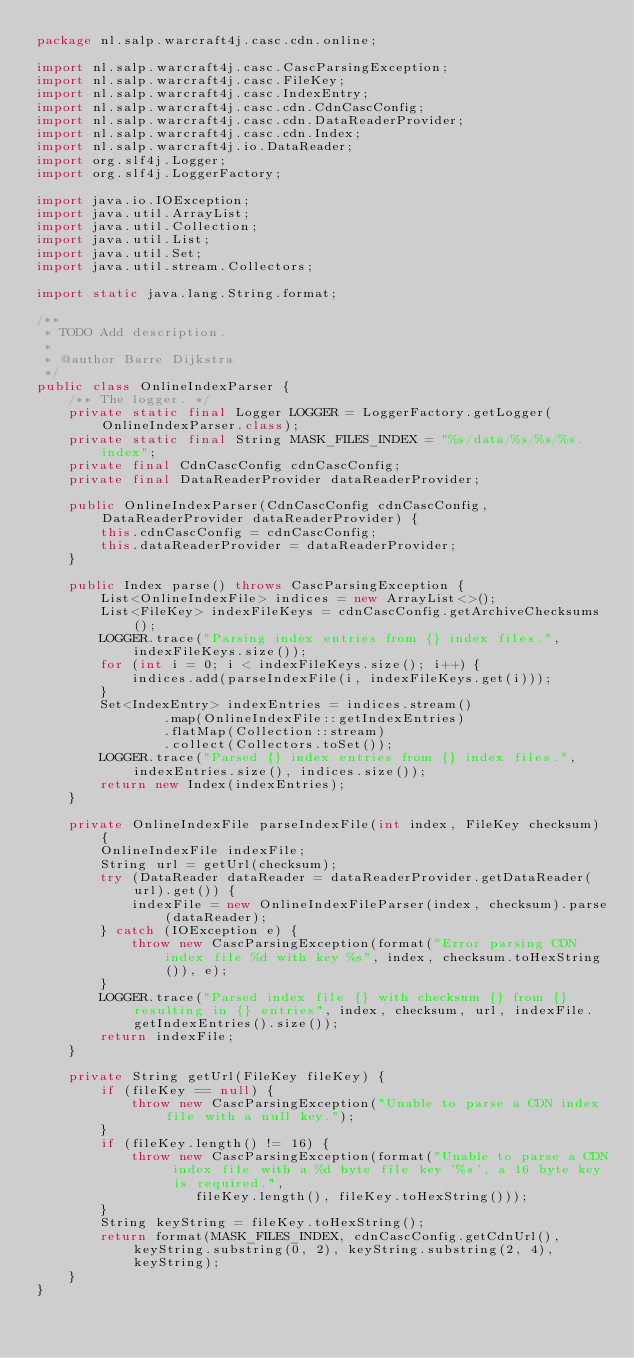<code> <loc_0><loc_0><loc_500><loc_500><_Java_>package nl.salp.warcraft4j.casc.cdn.online;

import nl.salp.warcraft4j.casc.CascParsingException;
import nl.salp.warcraft4j.casc.FileKey;
import nl.salp.warcraft4j.casc.IndexEntry;
import nl.salp.warcraft4j.casc.cdn.CdnCascConfig;
import nl.salp.warcraft4j.casc.cdn.DataReaderProvider;
import nl.salp.warcraft4j.casc.cdn.Index;
import nl.salp.warcraft4j.io.DataReader;
import org.slf4j.Logger;
import org.slf4j.LoggerFactory;

import java.io.IOException;
import java.util.ArrayList;
import java.util.Collection;
import java.util.List;
import java.util.Set;
import java.util.stream.Collectors;

import static java.lang.String.format;

/**
 * TODO Add description.
 *
 * @author Barre Dijkstra
 */
public class OnlineIndexParser {
    /** The logger. */
    private static final Logger LOGGER = LoggerFactory.getLogger(OnlineIndexParser.class);
    private static final String MASK_FILES_INDEX = "%s/data/%s/%s/%s.index";
    private final CdnCascConfig cdnCascConfig;
    private final DataReaderProvider dataReaderProvider;

    public OnlineIndexParser(CdnCascConfig cdnCascConfig, DataReaderProvider dataReaderProvider) {
        this.cdnCascConfig = cdnCascConfig;
        this.dataReaderProvider = dataReaderProvider;
    }

    public Index parse() throws CascParsingException {
        List<OnlineIndexFile> indices = new ArrayList<>();
        List<FileKey> indexFileKeys = cdnCascConfig.getArchiveChecksums();
        LOGGER.trace("Parsing index entries from {} index files.", indexFileKeys.size());
        for (int i = 0; i < indexFileKeys.size(); i++) {
            indices.add(parseIndexFile(i, indexFileKeys.get(i)));
        }
        Set<IndexEntry> indexEntries = indices.stream()
                .map(OnlineIndexFile::getIndexEntries)
                .flatMap(Collection::stream)
                .collect(Collectors.toSet());
        LOGGER.trace("Parsed {} index entries from {} index files.", indexEntries.size(), indices.size());
        return new Index(indexEntries);
    }

    private OnlineIndexFile parseIndexFile(int index, FileKey checksum) {
        OnlineIndexFile indexFile;
        String url = getUrl(checksum);
        try (DataReader dataReader = dataReaderProvider.getDataReader(url).get()) {
            indexFile = new OnlineIndexFileParser(index, checksum).parse(dataReader);
        } catch (IOException e) {
            throw new CascParsingException(format("Error parsing CDN index file %d with key %s", index, checksum.toHexString()), e);
        }
        LOGGER.trace("Parsed index file {} with checksum {} from {} resulting in {} entries", index, checksum, url, indexFile.getIndexEntries().size());
        return indexFile;
    }

    private String getUrl(FileKey fileKey) {
        if (fileKey == null) {
            throw new CascParsingException("Unable to parse a CDN index file with a null key.");
        }
        if (fileKey.length() != 16) {
            throw new CascParsingException(format("Unable to parse a CDN index file with a %d byte file key '%s', a 16 byte key is required.",
                    fileKey.length(), fileKey.toHexString()));
        }
        String keyString = fileKey.toHexString();
        return format(MASK_FILES_INDEX, cdnCascConfig.getCdnUrl(), keyString.substring(0, 2), keyString.substring(2, 4), keyString);
    }
}</code> 